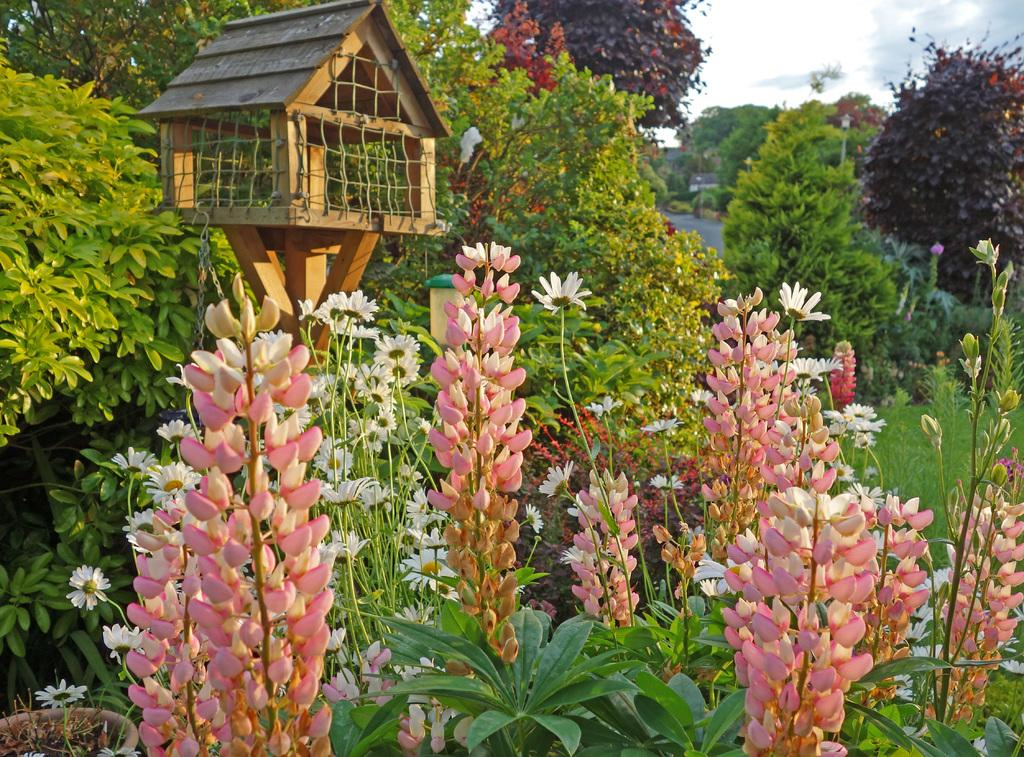What type of vegetation can be seen in the image? There are plants, trees, and flowers in the image. What type of ground cover is present in the image? There is grass in the image. What is visible in the sky in the image? The sky is visible in the image, and there are clouds present. What type of pet can be seen playing with the acoustics on the side of the image? There is no pet or acoustics present in the image. 